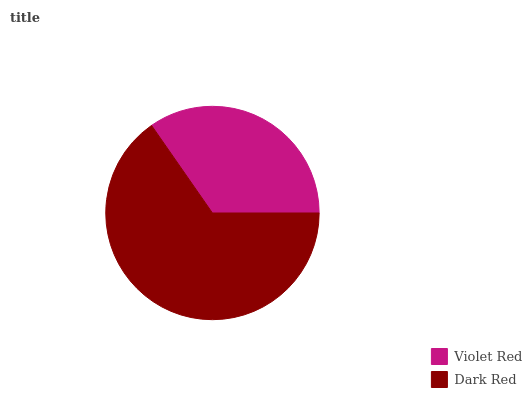Is Violet Red the minimum?
Answer yes or no. Yes. Is Dark Red the maximum?
Answer yes or no. Yes. Is Dark Red the minimum?
Answer yes or no. No. Is Dark Red greater than Violet Red?
Answer yes or no. Yes. Is Violet Red less than Dark Red?
Answer yes or no. Yes. Is Violet Red greater than Dark Red?
Answer yes or no. No. Is Dark Red less than Violet Red?
Answer yes or no. No. Is Dark Red the high median?
Answer yes or no. Yes. Is Violet Red the low median?
Answer yes or no. Yes. Is Violet Red the high median?
Answer yes or no. No. Is Dark Red the low median?
Answer yes or no. No. 